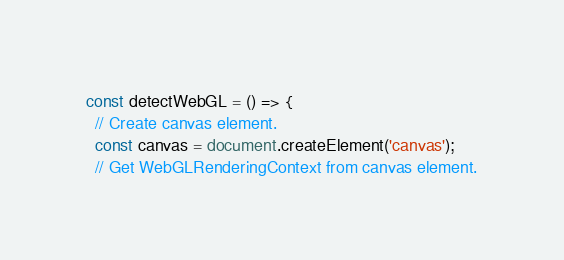<code> <loc_0><loc_0><loc_500><loc_500><_JavaScript_>const detectWebGL = () => {
  // Create canvas element.
  const canvas = document.createElement('canvas');
  // Get WebGLRenderingContext from canvas element.</code> 